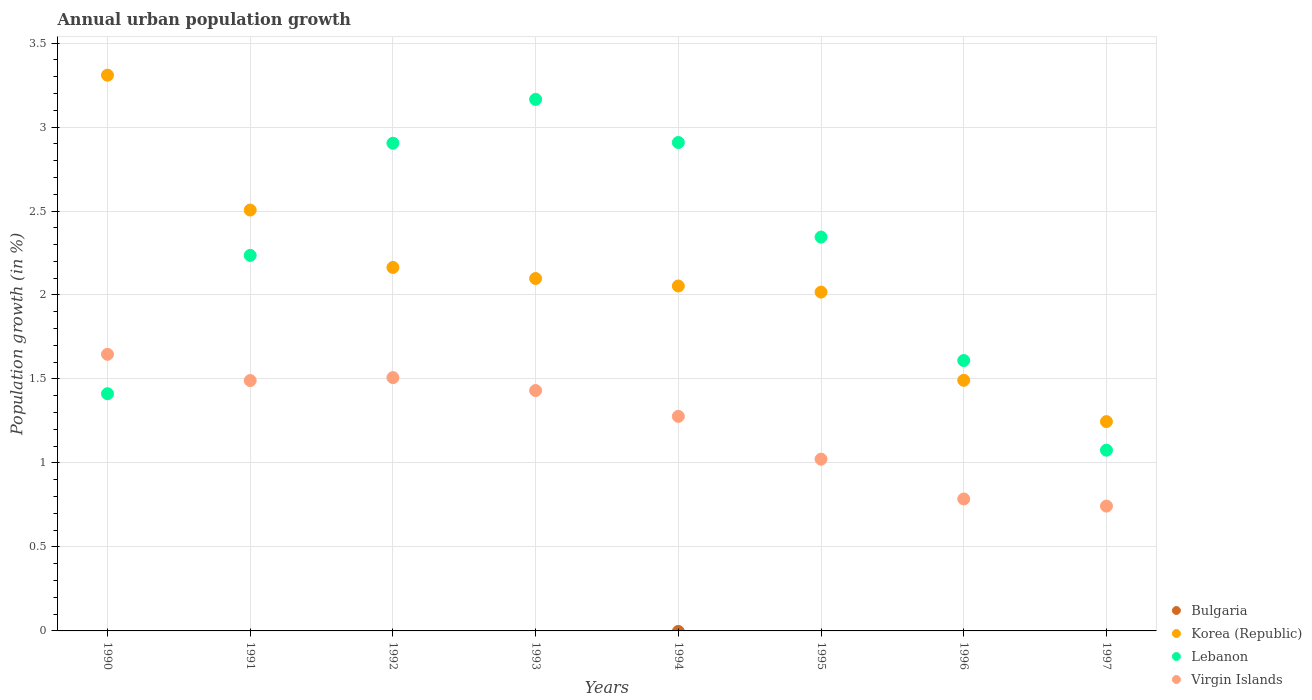What is the percentage of urban population growth in Lebanon in 1994?
Offer a terse response. 2.91. Across all years, what is the maximum percentage of urban population growth in Lebanon?
Provide a succinct answer. 3.16. Across all years, what is the minimum percentage of urban population growth in Virgin Islands?
Ensure brevity in your answer.  0.74. In which year was the percentage of urban population growth in Korea (Republic) maximum?
Give a very brief answer. 1990. What is the total percentage of urban population growth in Korea (Republic) in the graph?
Ensure brevity in your answer.  16.89. What is the difference between the percentage of urban population growth in Korea (Republic) in 1993 and that in 1997?
Ensure brevity in your answer.  0.85. What is the difference between the percentage of urban population growth in Lebanon in 1991 and the percentage of urban population growth in Korea (Republic) in 1992?
Your answer should be very brief. 0.07. What is the average percentage of urban population growth in Bulgaria per year?
Your response must be concise. 0. In the year 1996, what is the difference between the percentage of urban population growth in Virgin Islands and percentage of urban population growth in Lebanon?
Your response must be concise. -0.82. What is the ratio of the percentage of urban population growth in Lebanon in 1992 to that in 1996?
Provide a short and direct response. 1.8. Is the difference between the percentage of urban population growth in Virgin Islands in 1991 and 1992 greater than the difference between the percentage of urban population growth in Lebanon in 1991 and 1992?
Your answer should be compact. Yes. What is the difference between the highest and the second highest percentage of urban population growth in Lebanon?
Your response must be concise. 0.26. What is the difference between the highest and the lowest percentage of urban population growth in Lebanon?
Offer a terse response. 2.09. In how many years, is the percentage of urban population growth in Virgin Islands greater than the average percentage of urban population growth in Virgin Islands taken over all years?
Give a very brief answer. 5. Is the sum of the percentage of urban population growth in Lebanon in 1992 and 1996 greater than the maximum percentage of urban population growth in Bulgaria across all years?
Give a very brief answer. Yes. How many dotlines are there?
Your answer should be very brief. 3. How many years are there in the graph?
Give a very brief answer. 8. What is the difference between two consecutive major ticks on the Y-axis?
Your answer should be compact. 0.5. Does the graph contain any zero values?
Offer a very short reply. Yes. Where does the legend appear in the graph?
Provide a succinct answer. Bottom right. What is the title of the graph?
Make the answer very short. Annual urban population growth. Does "Singapore" appear as one of the legend labels in the graph?
Offer a terse response. No. What is the label or title of the X-axis?
Keep it short and to the point. Years. What is the label or title of the Y-axis?
Offer a very short reply. Population growth (in %). What is the Population growth (in %) in Bulgaria in 1990?
Provide a short and direct response. 0. What is the Population growth (in %) of Korea (Republic) in 1990?
Provide a succinct answer. 3.31. What is the Population growth (in %) in Lebanon in 1990?
Ensure brevity in your answer.  1.41. What is the Population growth (in %) of Virgin Islands in 1990?
Offer a very short reply. 1.65. What is the Population growth (in %) in Korea (Republic) in 1991?
Your response must be concise. 2.51. What is the Population growth (in %) in Lebanon in 1991?
Give a very brief answer. 2.24. What is the Population growth (in %) of Virgin Islands in 1991?
Ensure brevity in your answer.  1.49. What is the Population growth (in %) in Bulgaria in 1992?
Keep it short and to the point. 0. What is the Population growth (in %) in Korea (Republic) in 1992?
Provide a short and direct response. 2.16. What is the Population growth (in %) of Lebanon in 1992?
Your answer should be compact. 2.9. What is the Population growth (in %) of Virgin Islands in 1992?
Your answer should be very brief. 1.51. What is the Population growth (in %) in Korea (Republic) in 1993?
Give a very brief answer. 2.1. What is the Population growth (in %) in Lebanon in 1993?
Make the answer very short. 3.16. What is the Population growth (in %) of Virgin Islands in 1993?
Ensure brevity in your answer.  1.43. What is the Population growth (in %) of Bulgaria in 1994?
Make the answer very short. 0. What is the Population growth (in %) in Korea (Republic) in 1994?
Your answer should be compact. 2.05. What is the Population growth (in %) in Lebanon in 1994?
Your response must be concise. 2.91. What is the Population growth (in %) in Virgin Islands in 1994?
Your response must be concise. 1.28. What is the Population growth (in %) in Bulgaria in 1995?
Your answer should be very brief. 0. What is the Population growth (in %) in Korea (Republic) in 1995?
Provide a short and direct response. 2.02. What is the Population growth (in %) in Lebanon in 1995?
Offer a terse response. 2.34. What is the Population growth (in %) in Virgin Islands in 1995?
Your answer should be very brief. 1.02. What is the Population growth (in %) of Korea (Republic) in 1996?
Keep it short and to the point. 1.49. What is the Population growth (in %) in Lebanon in 1996?
Provide a succinct answer. 1.61. What is the Population growth (in %) of Virgin Islands in 1996?
Your answer should be compact. 0.79. What is the Population growth (in %) of Korea (Republic) in 1997?
Your answer should be very brief. 1.25. What is the Population growth (in %) of Lebanon in 1997?
Provide a succinct answer. 1.08. What is the Population growth (in %) in Virgin Islands in 1997?
Your answer should be very brief. 0.74. Across all years, what is the maximum Population growth (in %) in Korea (Republic)?
Give a very brief answer. 3.31. Across all years, what is the maximum Population growth (in %) of Lebanon?
Ensure brevity in your answer.  3.16. Across all years, what is the maximum Population growth (in %) of Virgin Islands?
Offer a terse response. 1.65. Across all years, what is the minimum Population growth (in %) in Korea (Republic)?
Ensure brevity in your answer.  1.25. Across all years, what is the minimum Population growth (in %) in Lebanon?
Offer a terse response. 1.08. Across all years, what is the minimum Population growth (in %) in Virgin Islands?
Ensure brevity in your answer.  0.74. What is the total Population growth (in %) in Bulgaria in the graph?
Provide a short and direct response. 0. What is the total Population growth (in %) of Korea (Republic) in the graph?
Keep it short and to the point. 16.89. What is the total Population growth (in %) in Lebanon in the graph?
Give a very brief answer. 17.65. What is the total Population growth (in %) of Virgin Islands in the graph?
Give a very brief answer. 9.91. What is the difference between the Population growth (in %) of Korea (Republic) in 1990 and that in 1991?
Offer a terse response. 0.8. What is the difference between the Population growth (in %) in Lebanon in 1990 and that in 1991?
Ensure brevity in your answer.  -0.82. What is the difference between the Population growth (in %) of Virgin Islands in 1990 and that in 1991?
Provide a succinct answer. 0.16. What is the difference between the Population growth (in %) in Korea (Republic) in 1990 and that in 1992?
Provide a succinct answer. 1.14. What is the difference between the Population growth (in %) of Lebanon in 1990 and that in 1992?
Keep it short and to the point. -1.49. What is the difference between the Population growth (in %) of Virgin Islands in 1990 and that in 1992?
Your response must be concise. 0.14. What is the difference between the Population growth (in %) in Korea (Republic) in 1990 and that in 1993?
Provide a short and direct response. 1.21. What is the difference between the Population growth (in %) in Lebanon in 1990 and that in 1993?
Offer a very short reply. -1.75. What is the difference between the Population growth (in %) in Virgin Islands in 1990 and that in 1993?
Your response must be concise. 0.22. What is the difference between the Population growth (in %) in Korea (Republic) in 1990 and that in 1994?
Your response must be concise. 1.26. What is the difference between the Population growth (in %) in Lebanon in 1990 and that in 1994?
Keep it short and to the point. -1.5. What is the difference between the Population growth (in %) in Virgin Islands in 1990 and that in 1994?
Offer a very short reply. 0.37. What is the difference between the Population growth (in %) in Korea (Republic) in 1990 and that in 1995?
Give a very brief answer. 1.29. What is the difference between the Population growth (in %) of Lebanon in 1990 and that in 1995?
Make the answer very short. -0.93. What is the difference between the Population growth (in %) of Virgin Islands in 1990 and that in 1995?
Provide a succinct answer. 0.62. What is the difference between the Population growth (in %) in Korea (Republic) in 1990 and that in 1996?
Your answer should be very brief. 1.82. What is the difference between the Population growth (in %) of Lebanon in 1990 and that in 1996?
Provide a short and direct response. -0.2. What is the difference between the Population growth (in %) of Virgin Islands in 1990 and that in 1996?
Your response must be concise. 0.86. What is the difference between the Population growth (in %) in Korea (Republic) in 1990 and that in 1997?
Provide a succinct answer. 2.06. What is the difference between the Population growth (in %) in Lebanon in 1990 and that in 1997?
Your answer should be compact. 0.34. What is the difference between the Population growth (in %) in Virgin Islands in 1990 and that in 1997?
Give a very brief answer. 0.9. What is the difference between the Population growth (in %) of Korea (Republic) in 1991 and that in 1992?
Make the answer very short. 0.34. What is the difference between the Population growth (in %) of Lebanon in 1991 and that in 1992?
Keep it short and to the point. -0.67. What is the difference between the Population growth (in %) in Virgin Islands in 1991 and that in 1992?
Offer a terse response. -0.02. What is the difference between the Population growth (in %) in Korea (Republic) in 1991 and that in 1993?
Your response must be concise. 0.41. What is the difference between the Population growth (in %) in Lebanon in 1991 and that in 1993?
Offer a terse response. -0.93. What is the difference between the Population growth (in %) in Virgin Islands in 1991 and that in 1993?
Your answer should be very brief. 0.06. What is the difference between the Population growth (in %) in Korea (Republic) in 1991 and that in 1994?
Ensure brevity in your answer.  0.45. What is the difference between the Population growth (in %) in Lebanon in 1991 and that in 1994?
Your answer should be very brief. -0.67. What is the difference between the Population growth (in %) of Virgin Islands in 1991 and that in 1994?
Keep it short and to the point. 0.21. What is the difference between the Population growth (in %) of Korea (Republic) in 1991 and that in 1995?
Provide a short and direct response. 0.49. What is the difference between the Population growth (in %) of Lebanon in 1991 and that in 1995?
Your answer should be very brief. -0.11. What is the difference between the Population growth (in %) of Virgin Islands in 1991 and that in 1995?
Offer a terse response. 0.47. What is the difference between the Population growth (in %) in Korea (Republic) in 1991 and that in 1996?
Your answer should be very brief. 1.01. What is the difference between the Population growth (in %) of Lebanon in 1991 and that in 1996?
Give a very brief answer. 0.63. What is the difference between the Population growth (in %) in Virgin Islands in 1991 and that in 1996?
Your answer should be compact. 0.7. What is the difference between the Population growth (in %) in Korea (Republic) in 1991 and that in 1997?
Provide a succinct answer. 1.26. What is the difference between the Population growth (in %) in Lebanon in 1991 and that in 1997?
Your answer should be compact. 1.16. What is the difference between the Population growth (in %) of Virgin Islands in 1991 and that in 1997?
Keep it short and to the point. 0.75. What is the difference between the Population growth (in %) of Korea (Republic) in 1992 and that in 1993?
Provide a succinct answer. 0.07. What is the difference between the Population growth (in %) in Lebanon in 1992 and that in 1993?
Offer a very short reply. -0.26. What is the difference between the Population growth (in %) in Virgin Islands in 1992 and that in 1993?
Give a very brief answer. 0.08. What is the difference between the Population growth (in %) of Korea (Republic) in 1992 and that in 1994?
Offer a very short reply. 0.11. What is the difference between the Population growth (in %) in Lebanon in 1992 and that in 1994?
Keep it short and to the point. -0. What is the difference between the Population growth (in %) in Virgin Islands in 1992 and that in 1994?
Ensure brevity in your answer.  0.23. What is the difference between the Population growth (in %) in Korea (Republic) in 1992 and that in 1995?
Give a very brief answer. 0.15. What is the difference between the Population growth (in %) in Lebanon in 1992 and that in 1995?
Provide a short and direct response. 0.56. What is the difference between the Population growth (in %) in Virgin Islands in 1992 and that in 1995?
Ensure brevity in your answer.  0.49. What is the difference between the Population growth (in %) of Korea (Republic) in 1992 and that in 1996?
Offer a terse response. 0.67. What is the difference between the Population growth (in %) in Lebanon in 1992 and that in 1996?
Make the answer very short. 1.29. What is the difference between the Population growth (in %) in Virgin Islands in 1992 and that in 1996?
Provide a short and direct response. 0.72. What is the difference between the Population growth (in %) of Korea (Republic) in 1992 and that in 1997?
Make the answer very short. 0.92. What is the difference between the Population growth (in %) of Lebanon in 1992 and that in 1997?
Make the answer very short. 1.83. What is the difference between the Population growth (in %) in Virgin Islands in 1992 and that in 1997?
Make the answer very short. 0.77. What is the difference between the Population growth (in %) in Korea (Republic) in 1993 and that in 1994?
Offer a very short reply. 0.04. What is the difference between the Population growth (in %) of Lebanon in 1993 and that in 1994?
Offer a terse response. 0.26. What is the difference between the Population growth (in %) of Virgin Islands in 1993 and that in 1994?
Provide a short and direct response. 0.15. What is the difference between the Population growth (in %) of Korea (Republic) in 1993 and that in 1995?
Offer a terse response. 0.08. What is the difference between the Population growth (in %) of Lebanon in 1993 and that in 1995?
Offer a very short reply. 0.82. What is the difference between the Population growth (in %) in Virgin Islands in 1993 and that in 1995?
Your answer should be very brief. 0.41. What is the difference between the Population growth (in %) in Korea (Republic) in 1993 and that in 1996?
Your answer should be compact. 0.61. What is the difference between the Population growth (in %) in Lebanon in 1993 and that in 1996?
Your answer should be very brief. 1.55. What is the difference between the Population growth (in %) of Virgin Islands in 1993 and that in 1996?
Provide a short and direct response. 0.65. What is the difference between the Population growth (in %) in Korea (Republic) in 1993 and that in 1997?
Give a very brief answer. 0.85. What is the difference between the Population growth (in %) in Lebanon in 1993 and that in 1997?
Provide a succinct answer. 2.09. What is the difference between the Population growth (in %) in Virgin Islands in 1993 and that in 1997?
Your answer should be very brief. 0.69. What is the difference between the Population growth (in %) in Korea (Republic) in 1994 and that in 1995?
Make the answer very short. 0.04. What is the difference between the Population growth (in %) of Lebanon in 1994 and that in 1995?
Offer a very short reply. 0.56. What is the difference between the Population growth (in %) of Virgin Islands in 1994 and that in 1995?
Your answer should be very brief. 0.25. What is the difference between the Population growth (in %) of Korea (Republic) in 1994 and that in 1996?
Your answer should be compact. 0.56. What is the difference between the Population growth (in %) of Lebanon in 1994 and that in 1996?
Give a very brief answer. 1.3. What is the difference between the Population growth (in %) in Virgin Islands in 1994 and that in 1996?
Offer a terse response. 0.49. What is the difference between the Population growth (in %) in Korea (Republic) in 1994 and that in 1997?
Offer a terse response. 0.81. What is the difference between the Population growth (in %) of Lebanon in 1994 and that in 1997?
Provide a succinct answer. 1.83. What is the difference between the Population growth (in %) in Virgin Islands in 1994 and that in 1997?
Give a very brief answer. 0.53. What is the difference between the Population growth (in %) of Korea (Republic) in 1995 and that in 1996?
Keep it short and to the point. 0.53. What is the difference between the Population growth (in %) in Lebanon in 1995 and that in 1996?
Offer a very short reply. 0.73. What is the difference between the Population growth (in %) of Virgin Islands in 1995 and that in 1996?
Give a very brief answer. 0.24. What is the difference between the Population growth (in %) in Korea (Republic) in 1995 and that in 1997?
Ensure brevity in your answer.  0.77. What is the difference between the Population growth (in %) in Lebanon in 1995 and that in 1997?
Your answer should be very brief. 1.27. What is the difference between the Population growth (in %) in Virgin Islands in 1995 and that in 1997?
Make the answer very short. 0.28. What is the difference between the Population growth (in %) in Korea (Republic) in 1996 and that in 1997?
Give a very brief answer. 0.25. What is the difference between the Population growth (in %) in Lebanon in 1996 and that in 1997?
Provide a succinct answer. 0.53. What is the difference between the Population growth (in %) in Virgin Islands in 1996 and that in 1997?
Your answer should be compact. 0.04. What is the difference between the Population growth (in %) of Korea (Republic) in 1990 and the Population growth (in %) of Lebanon in 1991?
Offer a very short reply. 1.07. What is the difference between the Population growth (in %) in Korea (Republic) in 1990 and the Population growth (in %) in Virgin Islands in 1991?
Provide a succinct answer. 1.82. What is the difference between the Population growth (in %) in Lebanon in 1990 and the Population growth (in %) in Virgin Islands in 1991?
Make the answer very short. -0.08. What is the difference between the Population growth (in %) in Korea (Republic) in 1990 and the Population growth (in %) in Lebanon in 1992?
Give a very brief answer. 0.41. What is the difference between the Population growth (in %) of Korea (Republic) in 1990 and the Population growth (in %) of Virgin Islands in 1992?
Offer a very short reply. 1.8. What is the difference between the Population growth (in %) of Lebanon in 1990 and the Population growth (in %) of Virgin Islands in 1992?
Give a very brief answer. -0.1. What is the difference between the Population growth (in %) in Korea (Republic) in 1990 and the Population growth (in %) in Lebanon in 1993?
Offer a very short reply. 0.14. What is the difference between the Population growth (in %) of Korea (Republic) in 1990 and the Population growth (in %) of Virgin Islands in 1993?
Keep it short and to the point. 1.88. What is the difference between the Population growth (in %) of Lebanon in 1990 and the Population growth (in %) of Virgin Islands in 1993?
Make the answer very short. -0.02. What is the difference between the Population growth (in %) of Korea (Republic) in 1990 and the Population growth (in %) of Lebanon in 1994?
Give a very brief answer. 0.4. What is the difference between the Population growth (in %) of Korea (Republic) in 1990 and the Population growth (in %) of Virgin Islands in 1994?
Ensure brevity in your answer.  2.03. What is the difference between the Population growth (in %) of Lebanon in 1990 and the Population growth (in %) of Virgin Islands in 1994?
Provide a succinct answer. 0.13. What is the difference between the Population growth (in %) in Korea (Republic) in 1990 and the Population growth (in %) in Lebanon in 1995?
Your answer should be compact. 0.96. What is the difference between the Population growth (in %) of Korea (Republic) in 1990 and the Population growth (in %) of Virgin Islands in 1995?
Your response must be concise. 2.29. What is the difference between the Population growth (in %) in Lebanon in 1990 and the Population growth (in %) in Virgin Islands in 1995?
Give a very brief answer. 0.39. What is the difference between the Population growth (in %) in Korea (Republic) in 1990 and the Population growth (in %) in Lebanon in 1996?
Keep it short and to the point. 1.7. What is the difference between the Population growth (in %) in Korea (Republic) in 1990 and the Population growth (in %) in Virgin Islands in 1996?
Give a very brief answer. 2.52. What is the difference between the Population growth (in %) in Lebanon in 1990 and the Population growth (in %) in Virgin Islands in 1996?
Offer a very short reply. 0.63. What is the difference between the Population growth (in %) of Korea (Republic) in 1990 and the Population growth (in %) of Lebanon in 1997?
Offer a terse response. 2.23. What is the difference between the Population growth (in %) in Korea (Republic) in 1990 and the Population growth (in %) in Virgin Islands in 1997?
Keep it short and to the point. 2.57. What is the difference between the Population growth (in %) of Lebanon in 1990 and the Population growth (in %) of Virgin Islands in 1997?
Your answer should be compact. 0.67. What is the difference between the Population growth (in %) in Korea (Republic) in 1991 and the Population growth (in %) in Lebanon in 1992?
Offer a very short reply. -0.4. What is the difference between the Population growth (in %) of Lebanon in 1991 and the Population growth (in %) of Virgin Islands in 1992?
Offer a terse response. 0.73. What is the difference between the Population growth (in %) of Korea (Republic) in 1991 and the Population growth (in %) of Lebanon in 1993?
Your response must be concise. -0.66. What is the difference between the Population growth (in %) of Korea (Republic) in 1991 and the Population growth (in %) of Virgin Islands in 1993?
Ensure brevity in your answer.  1.07. What is the difference between the Population growth (in %) of Lebanon in 1991 and the Population growth (in %) of Virgin Islands in 1993?
Your answer should be very brief. 0.8. What is the difference between the Population growth (in %) of Korea (Republic) in 1991 and the Population growth (in %) of Lebanon in 1994?
Ensure brevity in your answer.  -0.4. What is the difference between the Population growth (in %) of Korea (Republic) in 1991 and the Population growth (in %) of Virgin Islands in 1994?
Your answer should be very brief. 1.23. What is the difference between the Population growth (in %) of Lebanon in 1991 and the Population growth (in %) of Virgin Islands in 1994?
Your response must be concise. 0.96. What is the difference between the Population growth (in %) of Korea (Republic) in 1991 and the Population growth (in %) of Lebanon in 1995?
Your response must be concise. 0.16. What is the difference between the Population growth (in %) of Korea (Republic) in 1991 and the Population growth (in %) of Virgin Islands in 1995?
Provide a short and direct response. 1.48. What is the difference between the Population growth (in %) in Lebanon in 1991 and the Population growth (in %) in Virgin Islands in 1995?
Keep it short and to the point. 1.21. What is the difference between the Population growth (in %) of Korea (Republic) in 1991 and the Population growth (in %) of Lebanon in 1996?
Ensure brevity in your answer.  0.9. What is the difference between the Population growth (in %) of Korea (Republic) in 1991 and the Population growth (in %) of Virgin Islands in 1996?
Provide a short and direct response. 1.72. What is the difference between the Population growth (in %) in Lebanon in 1991 and the Population growth (in %) in Virgin Islands in 1996?
Your answer should be compact. 1.45. What is the difference between the Population growth (in %) in Korea (Republic) in 1991 and the Population growth (in %) in Lebanon in 1997?
Ensure brevity in your answer.  1.43. What is the difference between the Population growth (in %) in Korea (Republic) in 1991 and the Population growth (in %) in Virgin Islands in 1997?
Offer a terse response. 1.76. What is the difference between the Population growth (in %) of Lebanon in 1991 and the Population growth (in %) of Virgin Islands in 1997?
Your response must be concise. 1.49. What is the difference between the Population growth (in %) of Korea (Republic) in 1992 and the Population growth (in %) of Lebanon in 1993?
Offer a terse response. -1. What is the difference between the Population growth (in %) of Korea (Republic) in 1992 and the Population growth (in %) of Virgin Islands in 1993?
Offer a very short reply. 0.73. What is the difference between the Population growth (in %) of Lebanon in 1992 and the Population growth (in %) of Virgin Islands in 1993?
Ensure brevity in your answer.  1.47. What is the difference between the Population growth (in %) in Korea (Republic) in 1992 and the Population growth (in %) in Lebanon in 1994?
Offer a terse response. -0.74. What is the difference between the Population growth (in %) of Korea (Republic) in 1992 and the Population growth (in %) of Virgin Islands in 1994?
Offer a terse response. 0.89. What is the difference between the Population growth (in %) of Lebanon in 1992 and the Population growth (in %) of Virgin Islands in 1994?
Give a very brief answer. 1.63. What is the difference between the Population growth (in %) of Korea (Republic) in 1992 and the Population growth (in %) of Lebanon in 1995?
Your response must be concise. -0.18. What is the difference between the Population growth (in %) of Korea (Republic) in 1992 and the Population growth (in %) of Virgin Islands in 1995?
Offer a very short reply. 1.14. What is the difference between the Population growth (in %) of Lebanon in 1992 and the Population growth (in %) of Virgin Islands in 1995?
Give a very brief answer. 1.88. What is the difference between the Population growth (in %) in Korea (Republic) in 1992 and the Population growth (in %) in Lebanon in 1996?
Give a very brief answer. 0.55. What is the difference between the Population growth (in %) of Korea (Republic) in 1992 and the Population growth (in %) of Virgin Islands in 1996?
Make the answer very short. 1.38. What is the difference between the Population growth (in %) of Lebanon in 1992 and the Population growth (in %) of Virgin Islands in 1996?
Your response must be concise. 2.12. What is the difference between the Population growth (in %) in Korea (Republic) in 1992 and the Population growth (in %) in Lebanon in 1997?
Offer a terse response. 1.09. What is the difference between the Population growth (in %) in Korea (Republic) in 1992 and the Population growth (in %) in Virgin Islands in 1997?
Offer a very short reply. 1.42. What is the difference between the Population growth (in %) in Lebanon in 1992 and the Population growth (in %) in Virgin Islands in 1997?
Offer a terse response. 2.16. What is the difference between the Population growth (in %) of Korea (Republic) in 1993 and the Population growth (in %) of Lebanon in 1994?
Provide a succinct answer. -0.81. What is the difference between the Population growth (in %) of Korea (Republic) in 1993 and the Population growth (in %) of Virgin Islands in 1994?
Give a very brief answer. 0.82. What is the difference between the Population growth (in %) in Lebanon in 1993 and the Population growth (in %) in Virgin Islands in 1994?
Keep it short and to the point. 1.89. What is the difference between the Population growth (in %) of Korea (Republic) in 1993 and the Population growth (in %) of Lebanon in 1995?
Keep it short and to the point. -0.25. What is the difference between the Population growth (in %) in Korea (Republic) in 1993 and the Population growth (in %) in Virgin Islands in 1995?
Make the answer very short. 1.08. What is the difference between the Population growth (in %) in Lebanon in 1993 and the Population growth (in %) in Virgin Islands in 1995?
Make the answer very short. 2.14. What is the difference between the Population growth (in %) in Korea (Republic) in 1993 and the Population growth (in %) in Lebanon in 1996?
Your answer should be compact. 0.49. What is the difference between the Population growth (in %) in Korea (Republic) in 1993 and the Population growth (in %) in Virgin Islands in 1996?
Your answer should be compact. 1.31. What is the difference between the Population growth (in %) of Lebanon in 1993 and the Population growth (in %) of Virgin Islands in 1996?
Your response must be concise. 2.38. What is the difference between the Population growth (in %) of Korea (Republic) in 1993 and the Population growth (in %) of Virgin Islands in 1997?
Offer a terse response. 1.35. What is the difference between the Population growth (in %) in Lebanon in 1993 and the Population growth (in %) in Virgin Islands in 1997?
Provide a short and direct response. 2.42. What is the difference between the Population growth (in %) in Korea (Republic) in 1994 and the Population growth (in %) in Lebanon in 1995?
Give a very brief answer. -0.29. What is the difference between the Population growth (in %) in Korea (Republic) in 1994 and the Population growth (in %) in Virgin Islands in 1995?
Your answer should be very brief. 1.03. What is the difference between the Population growth (in %) of Lebanon in 1994 and the Population growth (in %) of Virgin Islands in 1995?
Give a very brief answer. 1.89. What is the difference between the Population growth (in %) of Korea (Republic) in 1994 and the Population growth (in %) of Lebanon in 1996?
Offer a terse response. 0.44. What is the difference between the Population growth (in %) in Korea (Republic) in 1994 and the Population growth (in %) in Virgin Islands in 1996?
Provide a short and direct response. 1.27. What is the difference between the Population growth (in %) in Lebanon in 1994 and the Population growth (in %) in Virgin Islands in 1996?
Give a very brief answer. 2.12. What is the difference between the Population growth (in %) in Korea (Republic) in 1994 and the Population growth (in %) in Lebanon in 1997?
Offer a terse response. 0.98. What is the difference between the Population growth (in %) in Korea (Republic) in 1994 and the Population growth (in %) in Virgin Islands in 1997?
Your response must be concise. 1.31. What is the difference between the Population growth (in %) in Lebanon in 1994 and the Population growth (in %) in Virgin Islands in 1997?
Give a very brief answer. 2.16. What is the difference between the Population growth (in %) of Korea (Republic) in 1995 and the Population growth (in %) of Lebanon in 1996?
Offer a very short reply. 0.41. What is the difference between the Population growth (in %) in Korea (Republic) in 1995 and the Population growth (in %) in Virgin Islands in 1996?
Your answer should be very brief. 1.23. What is the difference between the Population growth (in %) of Lebanon in 1995 and the Population growth (in %) of Virgin Islands in 1996?
Keep it short and to the point. 1.56. What is the difference between the Population growth (in %) of Korea (Republic) in 1995 and the Population growth (in %) of Lebanon in 1997?
Give a very brief answer. 0.94. What is the difference between the Population growth (in %) of Korea (Republic) in 1995 and the Population growth (in %) of Virgin Islands in 1997?
Offer a terse response. 1.27. What is the difference between the Population growth (in %) in Lebanon in 1995 and the Population growth (in %) in Virgin Islands in 1997?
Your response must be concise. 1.6. What is the difference between the Population growth (in %) of Korea (Republic) in 1996 and the Population growth (in %) of Lebanon in 1997?
Your answer should be very brief. 0.42. What is the difference between the Population growth (in %) of Korea (Republic) in 1996 and the Population growth (in %) of Virgin Islands in 1997?
Your answer should be compact. 0.75. What is the difference between the Population growth (in %) in Lebanon in 1996 and the Population growth (in %) in Virgin Islands in 1997?
Offer a terse response. 0.87. What is the average Population growth (in %) of Bulgaria per year?
Give a very brief answer. 0. What is the average Population growth (in %) of Korea (Republic) per year?
Keep it short and to the point. 2.11. What is the average Population growth (in %) in Lebanon per year?
Make the answer very short. 2.21. What is the average Population growth (in %) in Virgin Islands per year?
Offer a terse response. 1.24. In the year 1990, what is the difference between the Population growth (in %) of Korea (Republic) and Population growth (in %) of Lebanon?
Your answer should be very brief. 1.9. In the year 1990, what is the difference between the Population growth (in %) of Korea (Republic) and Population growth (in %) of Virgin Islands?
Offer a very short reply. 1.66. In the year 1990, what is the difference between the Population growth (in %) of Lebanon and Population growth (in %) of Virgin Islands?
Offer a very short reply. -0.23. In the year 1991, what is the difference between the Population growth (in %) in Korea (Republic) and Population growth (in %) in Lebanon?
Offer a very short reply. 0.27. In the year 1991, what is the difference between the Population growth (in %) in Korea (Republic) and Population growth (in %) in Virgin Islands?
Ensure brevity in your answer.  1.02. In the year 1991, what is the difference between the Population growth (in %) in Lebanon and Population growth (in %) in Virgin Islands?
Provide a short and direct response. 0.75. In the year 1992, what is the difference between the Population growth (in %) of Korea (Republic) and Population growth (in %) of Lebanon?
Offer a very short reply. -0.74. In the year 1992, what is the difference between the Population growth (in %) in Korea (Republic) and Population growth (in %) in Virgin Islands?
Keep it short and to the point. 0.66. In the year 1992, what is the difference between the Population growth (in %) in Lebanon and Population growth (in %) in Virgin Islands?
Your answer should be compact. 1.4. In the year 1993, what is the difference between the Population growth (in %) of Korea (Republic) and Population growth (in %) of Lebanon?
Offer a terse response. -1.07. In the year 1993, what is the difference between the Population growth (in %) in Korea (Republic) and Population growth (in %) in Virgin Islands?
Ensure brevity in your answer.  0.67. In the year 1993, what is the difference between the Population growth (in %) of Lebanon and Population growth (in %) of Virgin Islands?
Offer a very short reply. 1.73. In the year 1994, what is the difference between the Population growth (in %) in Korea (Republic) and Population growth (in %) in Lebanon?
Your response must be concise. -0.85. In the year 1994, what is the difference between the Population growth (in %) of Korea (Republic) and Population growth (in %) of Virgin Islands?
Provide a short and direct response. 0.78. In the year 1994, what is the difference between the Population growth (in %) of Lebanon and Population growth (in %) of Virgin Islands?
Offer a very short reply. 1.63. In the year 1995, what is the difference between the Population growth (in %) of Korea (Republic) and Population growth (in %) of Lebanon?
Your answer should be very brief. -0.33. In the year 1995, what is the difference between the Population growth (in %) in Korea (Republic) and Population growth (in %) in Virgin Islands?
Give a very brief answer. 0.99. In the year 1995, what is the difference between the Population growth (in %) in Lebanon and Population growth (in %) in Virgin Islands?
Ensure brevity in your answer.  1.32. In the year 1996, what is the difference between the Population growth (in %) in Korea (Republic) and Population growth (in %) in Lebanon?
Ensure brevity in your answer.  -0.12. In the year 1996, what is the difference between the Population growth (in %) in Korea (Republic) and Population growth (in %) in Virgin Islands?
Give a very brief answer. 0.71. In the year 1996, what is the difference between the Population growth (in %) of Lebanon and Population growth (in %) of Virgin Islands?
Give a very brief answer. 0.82. In the year 1997, what is the difference between the Population growth (in %) in Korea (Republic) and Population growth (in %) in Lebanon?
Offer a very short reply. 0.17. In the year 1997, what is the difference between the Population growth (in %) in Korea (Republic) and Population growth (in %) in Virgin Islands?
Give a very brief answer. 0.5. In the year 1997, what is the difference between the Population growth (in %) in Lebanon and Population growth (in %) in Virgin Islands?
Offer a terse response. 0.33. What is the ratio of the Population growth (in %) in Korea (Republic) in 1990 to that in 1991?
Provide a succinct answer. 1.32. What is the ratio of the Population growth (in %) in Lebanon in 1990 to that in 1991?
Your response must be concise. 0.63. What is the ratio of the Population growth (in %) of Virgin Islands in 1990 to that in 1991?
Your answer should be compact. 1.1. What is the ratio of the Population growth (in %) of Korea (Republic) in 1990 to that in 1992?
Your answer should be very brief. 1.53. What is the ratio of the Population growth (in %) of Lebanon in 1990 to that in 1992?
Your response must be concise. 0.49. What is the ratio of the Population growth (in %) in Virgin Islands in 1990 to that in 1992?
Your answer should be very brief. 1.09. What is the ratio of the Population growth (in %) of Korea (Republic) in 1990 to that in 1993?
Offer a very short reply. 1.58. What is the ratio of the Population growth (in %) in Lebanon in 1990 to that in 1993?
Provide a short and direct response. 0.45. What is the ratio of the Population growth (in %) of Virgin Islands in 1990 to that in 1993?
Give a very brief answer. 1.15. What is the ratio of the Population growth (in %) in Korea (Republic) in 1990 to that in 1994?
Make the answer very short. 1.61. What is the ratio of the Population growth (in %) in Lebanon in 1990 to that in 1994?
Your answer should be very brief. 0.49. What is the ratio of the Population growth (in %) of Virgin Islands in 1990 to that in 1994?
Give a very brief answer. 1.29. What is the ratio of the Population growth (in %) of Korea (Republic) in 1990 to that in 1995?
Your answer should be compact. 1.64. What is the ratio of the Population growth (in %) in Lebanon in 1990 to that in 1995?
Provide a short and direct response. 0.6. What is the ratio of the Population growth (in %) of Virgin Islands in 1990 to that in 1995?
Offer a very short reply. 1.61. What is the ratio of the Population growth (in %) in Korea (Republic) in 1990 to that in 1996?
Provide a succinct answer. 2.22. What is the ratio of the Population growth (in %) in Lebanon in 1990 to that in 1996?
Provide a succinct answer. 0.88. What is the ratio of the Population growth (in %) of Virgin Islands in 1990 to that in 1996?
Your answer should be very brief. 2.1. What is the ratio of the Population growth (in %) of Korea (Republic) in 1990 to that in 1997?
Make the answer very short. 2.66. What is the ratio of the Population growth (in %) in Lebanon in 1990 to that in 1997?
Your response must be concise. 1.31. What is the ratio of the Population growth (in %) in Virgin Islands in 1990 to that in 1997?
Your answer should be compact. 2.22. What is the ratio of the Population growth (in %) in Korea (Republic) in 1991 to that in 1992?
Your answer should be very brief. 1.16. What is the ratio of the Population growth (in %) of Lebanon in 1991 to that in 1992?
Your answer should be very brief. 0.77. What is the ratio of the Population growth (in %) of Virgin Islands in 1991 to that in 1992?
Keep it short and to the point. 0.99. What is the ratio of the Population growth (in %) in Korea (Republic) in 1991 to that in 1993?
Your answer should be compact. 1.19. What is the ratio of the Population growth (in %) of Lebanon in 1991 to that in 1993?
Make the answer very short. 0.71. What is the ratio of the Population growth (in %) of Virgin Islands in 1991 to that in 1993?
Offer a very short reply. 1.04. What is the ratio of the Population growth (in %) of Korea (Republic) in 1991 to that in 1994?
Ensure brevity in your answer.  1.22. What is the ratio of the Population growth (in %) of Lebanon in 1991 to that in 1994?
Your answer should be very brief. 0.77. What is the ratio of the Population growth (in %) of Virgin Islands in 1991 to that in 1994?
Give a very brief answer. 1.17. What is the ratio of the Population growth (in %) in Korea (Republic) in 1991 to that in 1995?
Your response must be concise. 1.24. What is the ratio of the Population growth (in %) of Lebanon in 1991 to that in 1995?
Keep it short and to the point. 0.95. What is the ratio of the Population growth (in %) of Virgin Islands in 1991 to that in 1995?
Offer a terse response. 1.46. What is the ratio of the Population growth (in %) in Korea (Republic) in 1991 to that in 1996?
Ensure brevity in your answer.  1.68. What is the ratio of the Population growth (in %) of Lebanon in 1991 to that in 1996?
Give a very brief answer. 1.39. What is the ratio of the Population growth (in %) of Virgin Islands in 1991 to that in 1996?
Ensure brevity in your answer.  1.9. What is the ratio of the Population growth (in %) in Korea (Republic) in 1991 to that in 1997?
Your response must be concise. 2.01. What is the ratio of the Population growth (in %) in Lebanon in 1991 to that in 1997?
Offer a terse response. 2.08. What is the ratio of the Population growth (in %) in Virgin Islands in 1991 to that in 1997?
Your response must be concise. 2.01. What is the ratio of the Population growth (in %) of Korea (Republic) in 1992 to that in 1993?
Your response must be concise. 1.03. What is the ratio of the Population growth (in %) in Lebanon in 1992 to that in 1993?
Give a very brief answer. 0.92. What is the ratio of the Population growth (in %) in Virgin Islands in 1992 to that in 1993?
Provide a short and direct response. 1.05. What is the ratio of the Population growth (in %) of Korea (Republic) in 1992 to that in 1994?
Your answer should be compact. 1.05. What is the ratio of the Population growth (in %) in Lebanon in 1992 to that in 1994?
Offer a very short reply. 1. What is the ratio of the Population growth (in %) of Virgin Islands in 1992 to that in 1994?
Offer a terse response. 1.18. What is the ratio of the Population growth (in %) of Korea (Republic) in 1992 to that in 1995?
Your answer should be very brief. 1.07. What is the ratio of the Population growth (in %) in Lebanon in 1992 to that in 1995?
Your response must be concise. 1.24. What is the ratio of the Population growth (in %) in Virgin Islands in 1992 to that in 1995?
Your answer should be very brief. 1.47. What is the ratio of the Population growth (in %) in Korea (Republic) in 1992 to that in 1996?
Ensure brevity in your answer.  1.45. What is the ratio of the Population growth (in %) of Lebanon in 1992 to that in 1996?
Your answer should be very brief. 1.8. What is the ratio of the Population growth (in %) of Virgin Islands in 1992 to that in 1996?
Keep it short and to the point. 1.92. What is the ratio of the Population growth (in %) in Korea (Republic) in 1992 to that in 1997?
Make the answer very short. 1.74. What is the ratio of the Population growth (in %) of Lebanon in 1992 to that in 1997?
Give a very brief answer. 2.7. What is the ratio of the Population growth (in %) of Virgin Islands in 1992 to that in 1997?
Provide a succinct answer. 2.03. What is the ratio of the Population growth (in %) in Korea (Republic) in 1993 to that in 1994?
Ensure brevity in your answer.  1.02. What is the ratio of the Population growth (in %) in Lebanon in 1993 to that in 1994?
Make the answer very short. 1.09. What is the ratio of the Population growth (in %) in Virgin Islands in 1993 to that in 1994?
Ensure brevity in your answer.  1.12. What is the ratio of the Population growth (in %) of Korea (Republic) in 1993 to that in 1995?
Keep it short and to the point. 1.04. What is the ratio of the Population growth (in %) of Lebanon in 1993 to that in 1995?
Your answer should be very brief. 1.35. What is the ratio of the Population growth (in %) in Virgin Islands in 1993 to that in 1995?
Your answer should be compact. 1.4. What is the ratio of the Population growth (in %) of Korea (Republic) in 1993 to that in 1996?
Your answer should be very brief. 1.41. What is the ratio of the Population growth (in %) of Lebanon in 1993 to that in 1996?
Ensure brevity in your answer.  1.97. What is the ratio of the Population growth (in %) of Virgin Islands in 1993 to that in 1996?
Your response must be concise. 1.82. What is the ratio of the Population growth (in %) in Korea (Republic) in 1993 to that in 1997?
Make the answer very short. 1.68. What is the ratio of the Population growth (in %) in Lebanon in 1993 to that in 1997?
Offer a terse response. 2.94. What is the ratio of the Population growth (in %) of Virgin Islands in 1993 to that in 1997?
Your answer should be compact. 1.93. What is the ratio of the Population growth (in %) in Lebanon in 1994 to that in 1995?
Your answer should be very brief. 1.24. What is the ratio of the Population growth (in %) in Virgin Islands in 1994 to that in 1995?
Provide a short and direct response. 1.25. What is the ratio of the Population growth (in %) of Korea (Republic) in 1994 to that in 1996?
Ensure brevity in your answer.  1.38. What is the ratio of the Population growth (in %) in Lebanon in 1994 to that in 1996?
Provide a short and direct response. 1.81. What is the ratio of the Population growth (in %) of Virgin Islands in 1994 to that in 1996?
Provide a succinct answer. 1.63. What is the ratio of the Population growth (in %) of Korea (Republic) in 1994 to that in 1997?
Make the answer very short. 1.65. What is the ratio of the Population growth (in %) of Lebanon in 1994 to that in 1997?
Your response must be concise. 2.7. What is the ratio of the Population growth (in %) in Virgin Islands in 1994 to that in 1997?
Keep it short and to the point. 1.72. What is the ratio of the Population growth (in %) of Korea (Republic) in 1995 to that in 1996?
Your answer should be compact. 1.35. What is the ratio of the Population growth (in %) of Lebanon in 1995 to that in 1996?
Make the answer very short. 1.46. What is the ratio of the Population growth (in %) of Virgin Islands in 1995 to that in 1996?
Offer a very short reply. 1.3. What is the ratio of the Population growth (in %) in Korea (Republic) in 1995 to that in 1997?
Your answer should be compact. 1.62. What is the ratio of the Population growth (in %) in Lebanon in 1995 to that in 1997?
Keep it short and to the point. 2.18. What is the ratio of the Population growth (in %) in Virgin Islands in 1995 to that in 1997?
Make the answer very short. 1.38. What is the ratio of the Population growth (in %) in Korea (Republic) in 1996 to that in 1997?
Provide a short and direct response. 1.2. What is the ratio of the Population growth (in %) in Lebanon in 1996 to that in 1997?
Your answer should be very brief. 1.5. What is the ratio of the Population growth (in %) in Virgin Islands in 1996 to that in 1997?
Provide a succinct answer. 1.06. What is the difference between the highest and the second highest Population growth (in %) of Korea (Republic)?
Your response must be concise. 0.8. What is the difference between the highest and the second highest Population growth (in %) in Lebanon?
Offer a very short reply. 0.26. What is the difference between the highest and the second highest Population growth (in %) in Virgin Islands?
Make the answer very short. 0.14. What is the difference between the highest and the lowest Population growth (in %) in Korea (Republic)?
Make the answer very short. 2.06. What is the difference between the highest and the lowest Population growth (in %) in Lebanon?
Provide a short and direct response. 2.09. What is the difference between the highest and the lowest Population growth (in %) of Virgin Islands?
Your response must be concise. 0.9. 